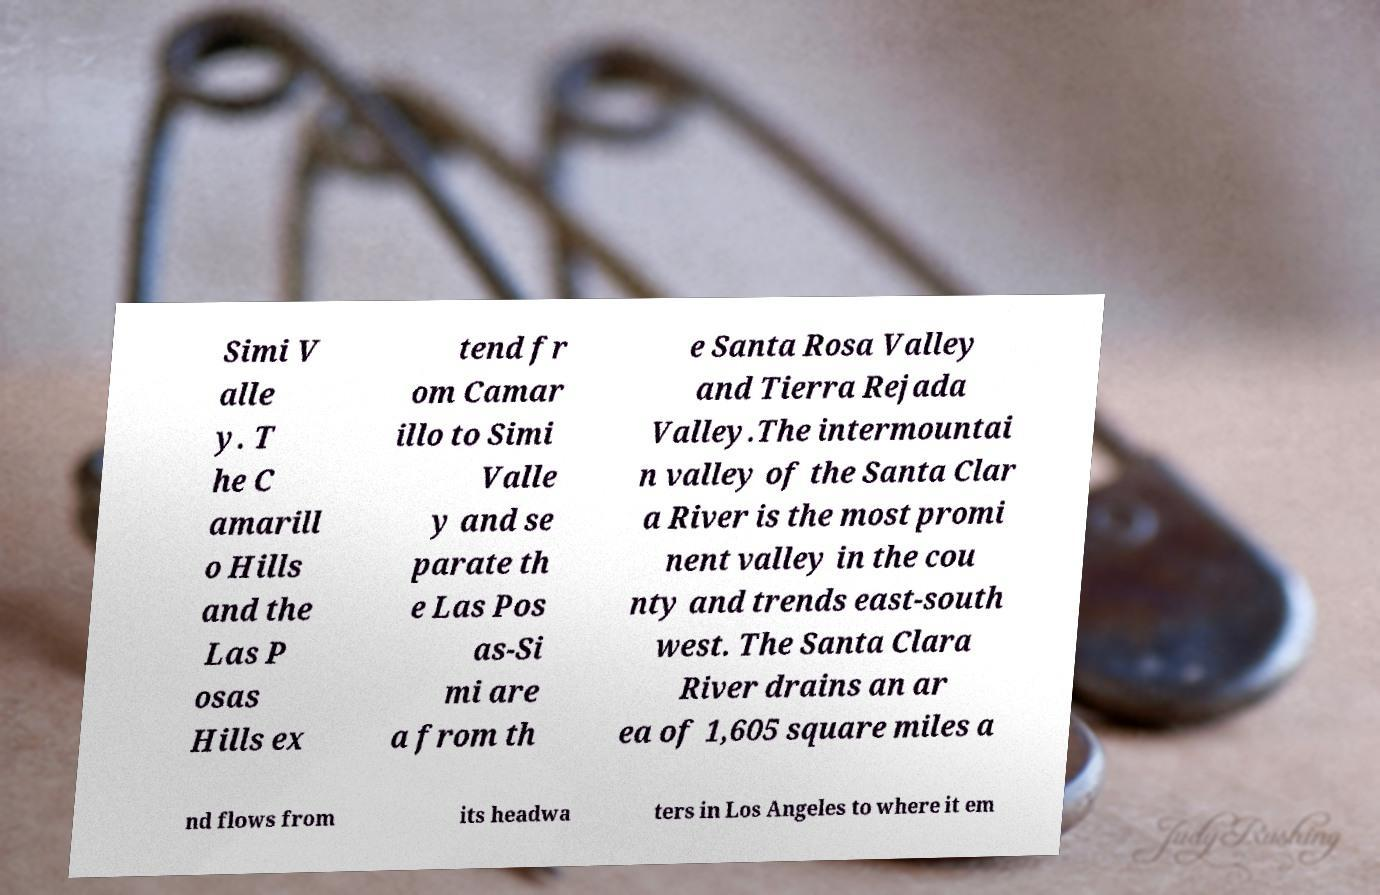What messages or text are displayed in this image? I need them in a readable, typed format. Simi V alle y. T he C amarill o Hills and the Las P osas Hills ex tend fr om Camar illo to Simi Valle y and se parate th e Las Pos as-Si mi are a from th e Santa Rosa Valley and Tierra Rejada Valley.The intermountai n valley of the Santa Clar a River is the most promi nent valley in the cou nty and trends east-south west. The Santa Clara River drains an ar ea of 1,605 square miles a nd flows from its headwa ters in Los Angeles to where it em 